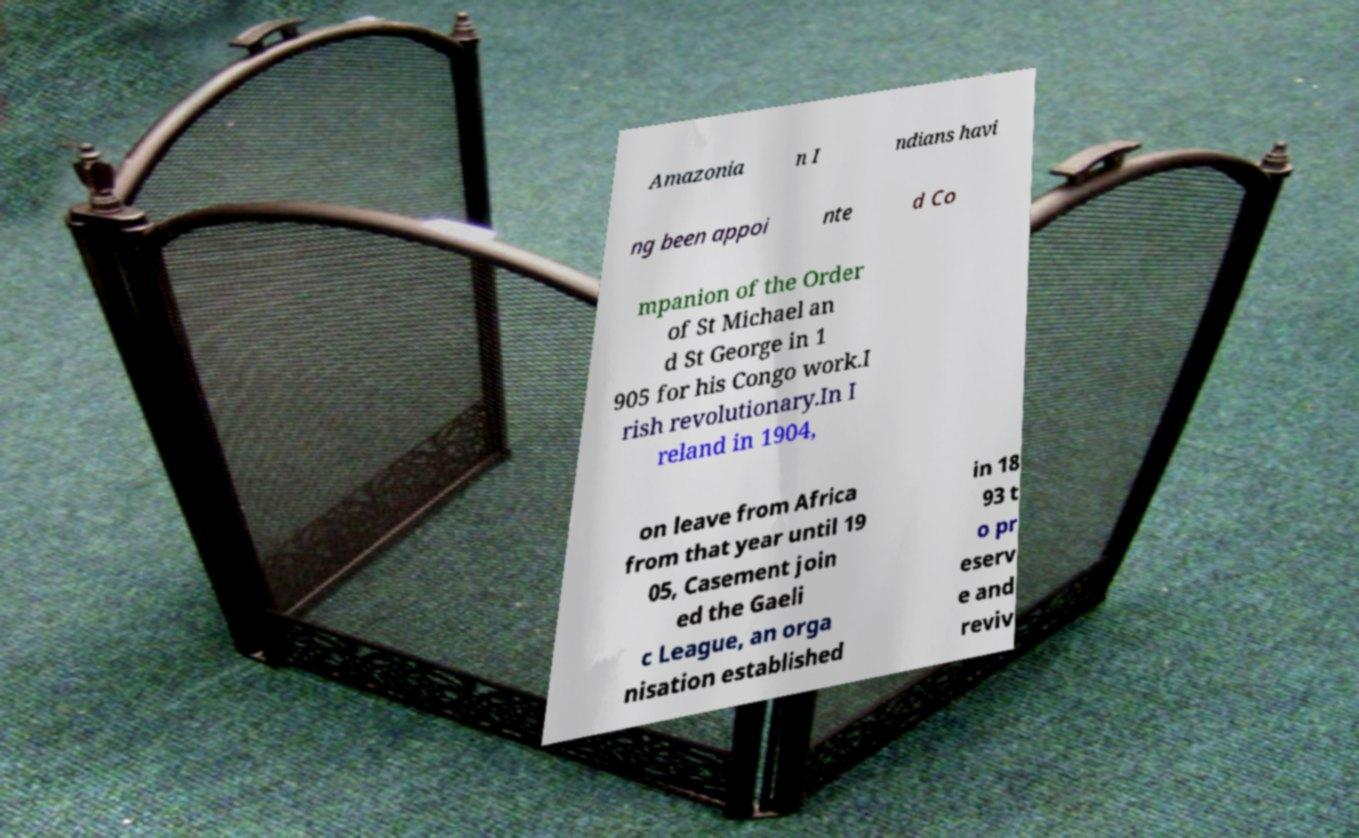For documentation purposes, I need the text within this image transcribed. Could you provide that? Amazonia n I ndians havi ng been appoi nte d Co mpanion of the Order of St Michael an d St George in 1 905 for his Congo work.I rish revolutionary.In I reland in 1904, on leave from Africa from that year until 19 05, Casement join ed the Gaeli c League, an orga nisation established in 18 93 t o pr eserv e and reviv 